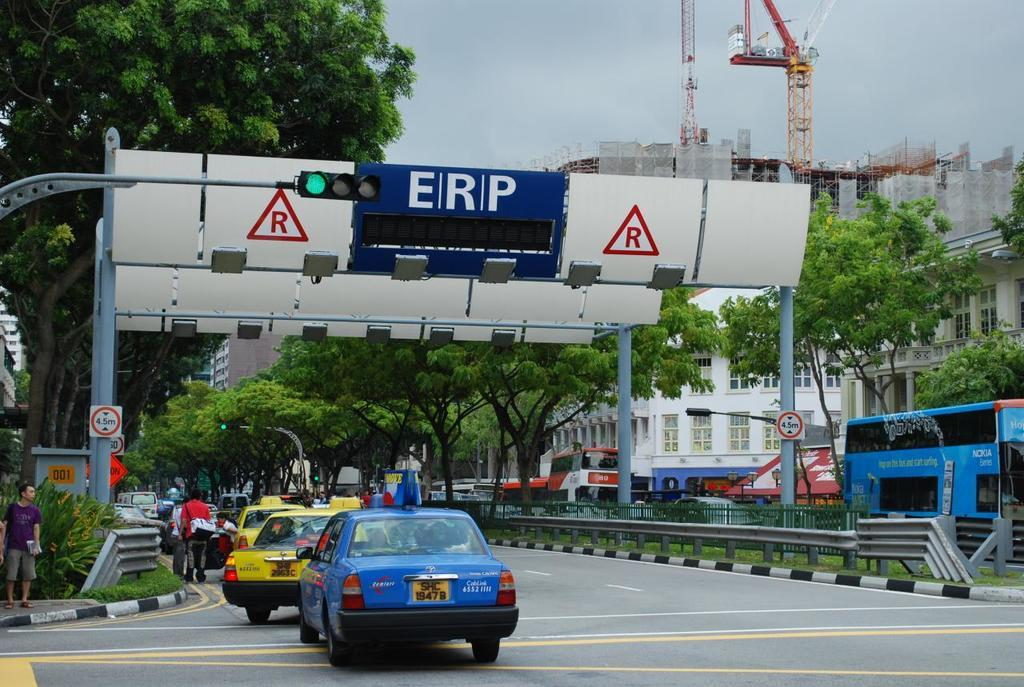<image>
Provide a brief description of the given image. Cars drive under a sign that reads ERP. 